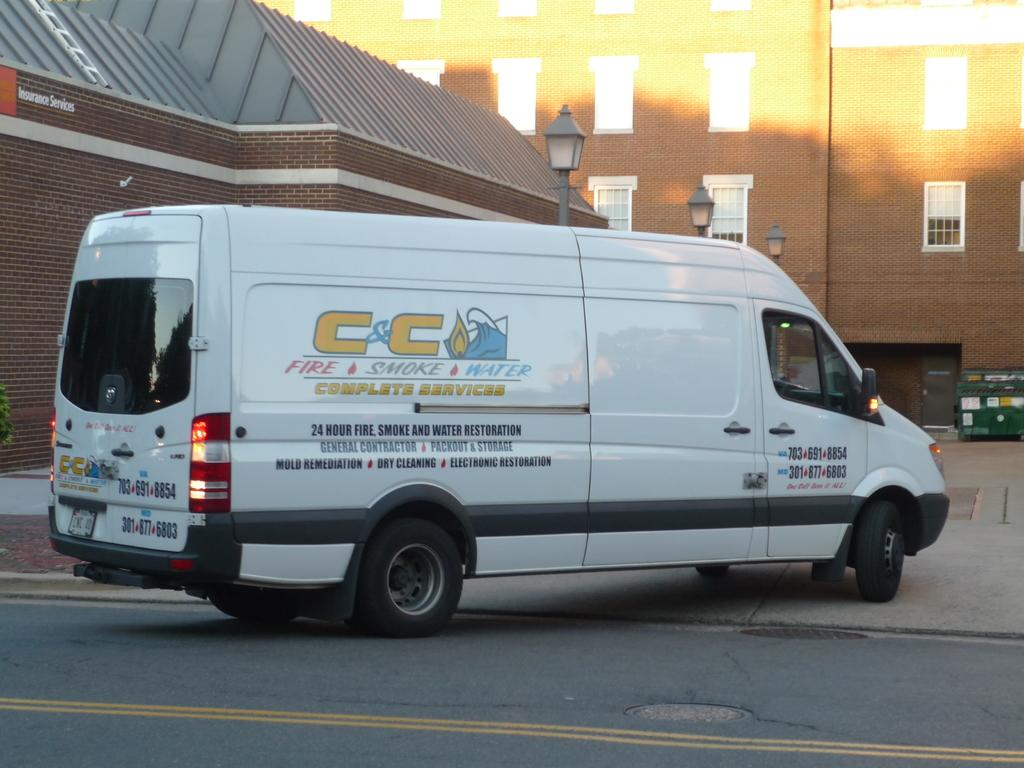<image>
Describe the image concisely. white fire and smoke van sits in parking lot 